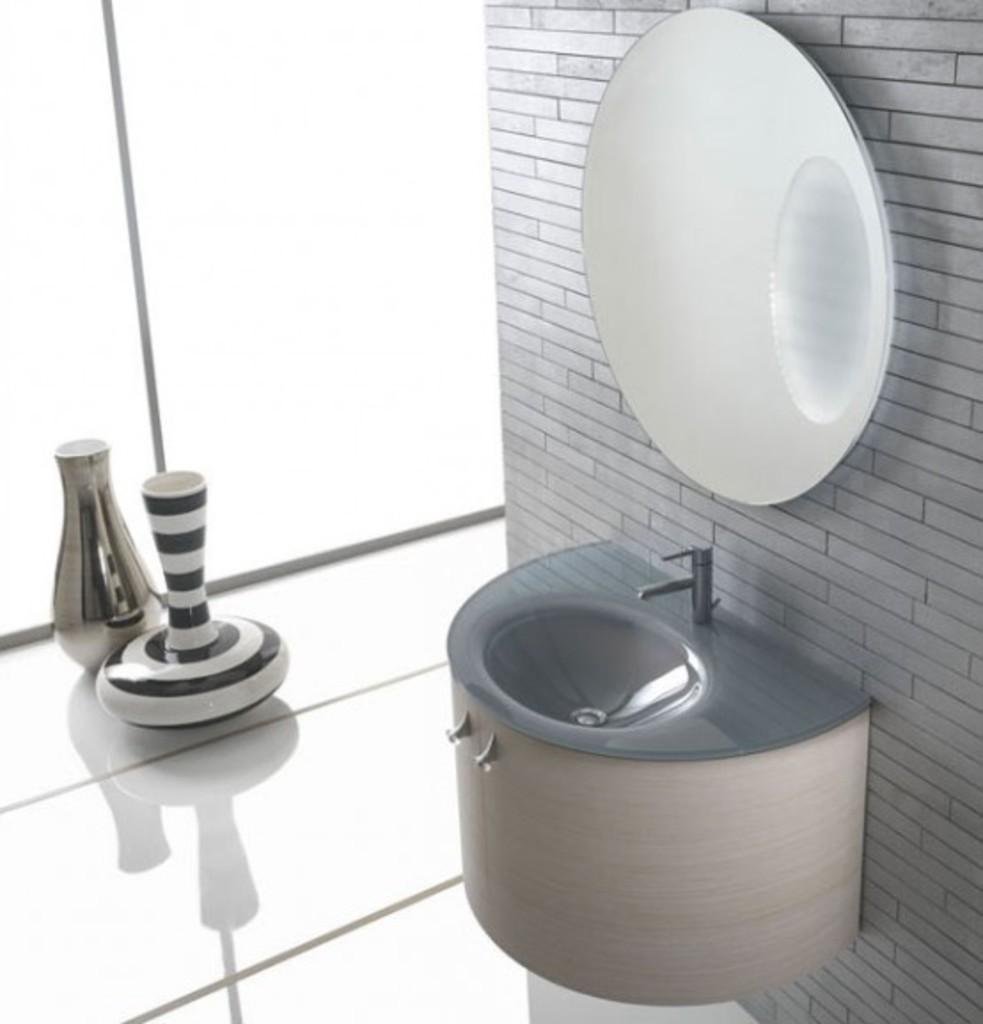Could you give a brief overview of what you see in this image? In this image we can see a sink and there is a mirror placed on the wall. On the left there are vases placed on the surface. In the background there is a wall. 